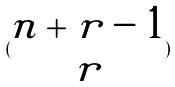Convert formula to latex. <formula><loc_0><loc_0><loc_500><loc_500>( \begin{matrix} n + r - 1 \\ r \end{matrix} )</formula> 